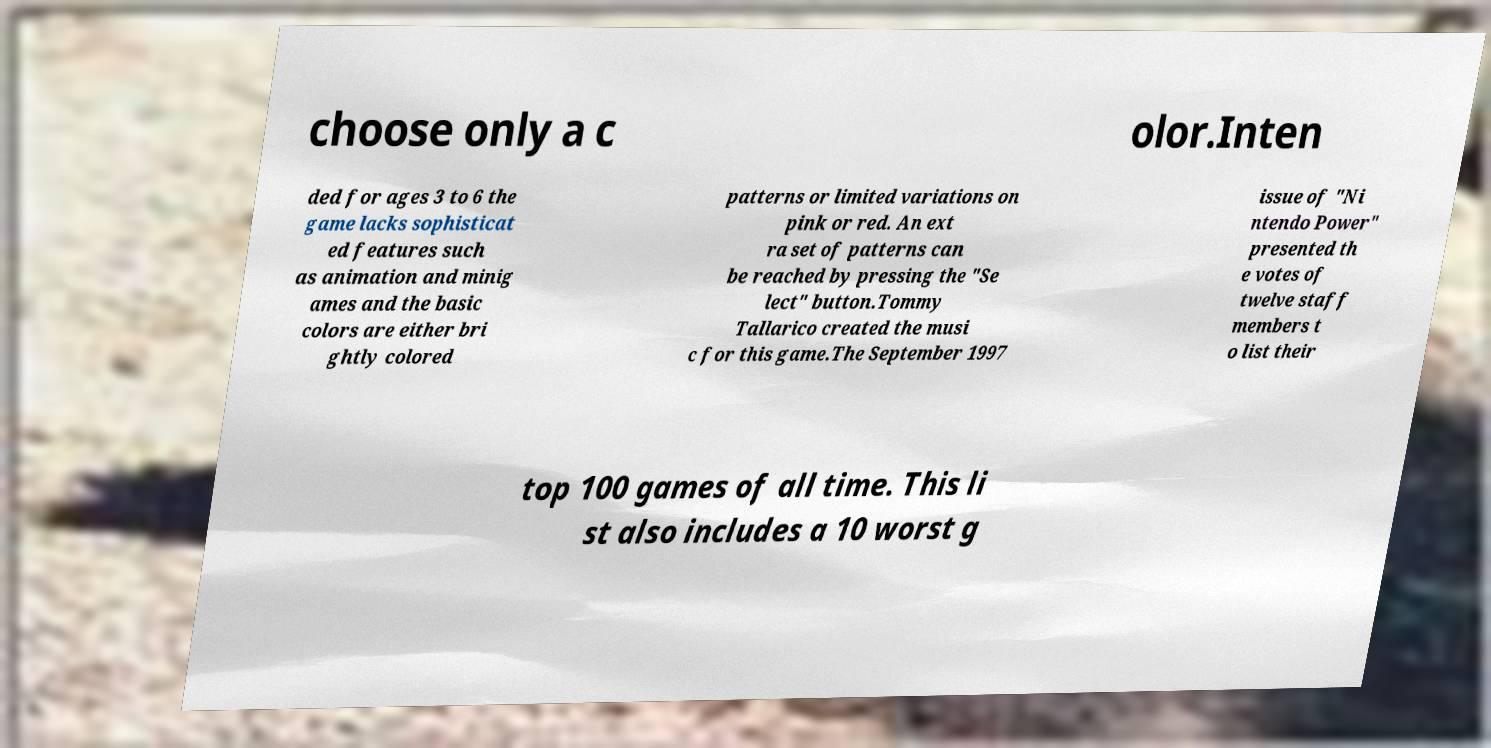There's text embedded in this image that I need extracted. Can you transcribe it verbatim? choose only a c olor.Inten ded for ages 3 to 6 the game lacks sophisticat ed features such as animation and minig ames and the basic colors are either bri ghtly colored patterns or limited variations on pink or red. An ext ra set of patterns can be reached by pressing the "Se lect" button.Tommy Tallarico created the musi c for this game.The September 1997 issue of "Ni ntendo Power" presented th e votes of twelve staff members t o list their top 100 games of all time. This li st also includes a 10 worst g 